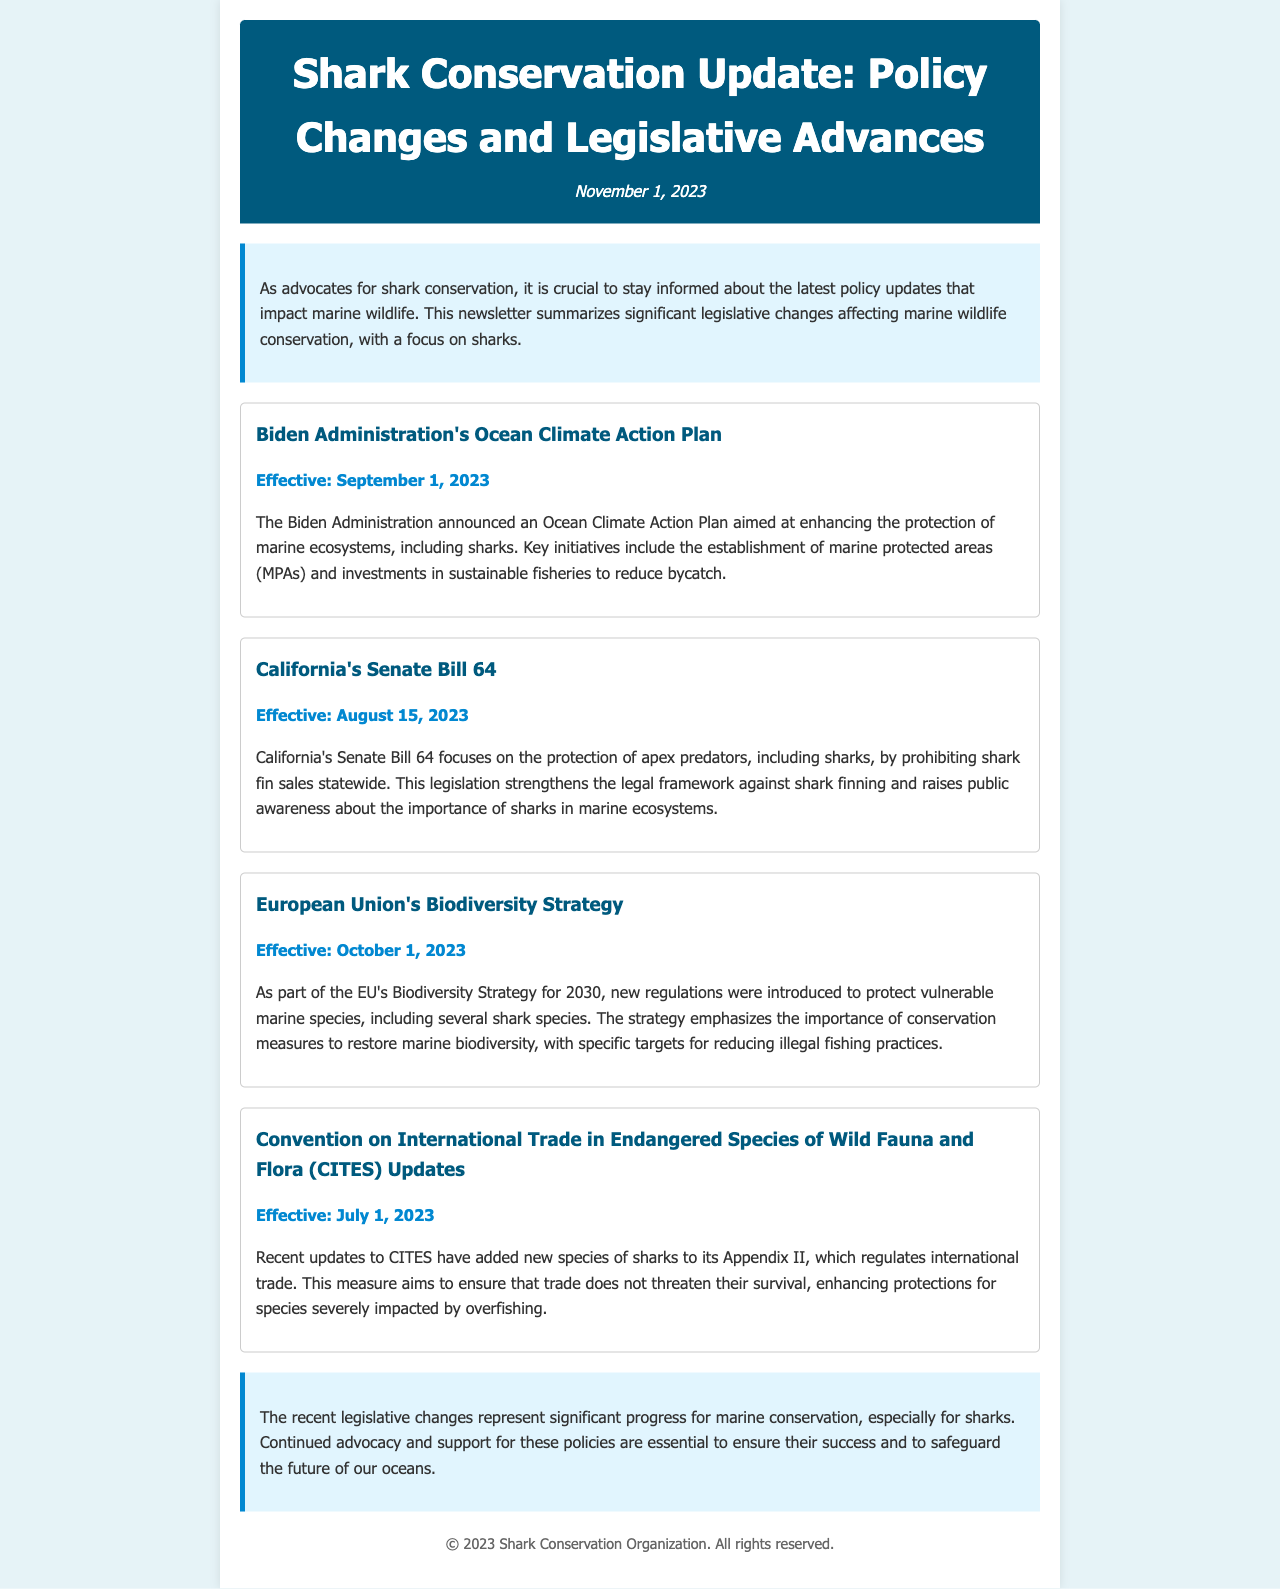What is the title of the newsletter? The title is stated in the header of the newsletter, which reflects its focus on policy changes related to marine wildlife conservation.
Answer: Shark Conservation Update: Policy Changes and Legislative Advances When was the Ocean Climate Action Plan effective? The effective date of the Ocean Climate Action Plan is mentioned in the policy update section, providing a specific timeline for its implementation.
Answer: September 1, 2023 What does California's Senate Bill 64 prohibit? This information is found in the description of California's Senate Bill 64, outlining its specific focus on shark conservation measures.
Answer: Shark fin sales Which organization announced updates to CITES? The updates to CITES are referenced within the legislative changes section of the document, pointing to the authority behind the regulation.
Answer: Convention on International Trade in Endangered Species of Wild Fauna and Flora (CITES) What is the main goal of the European Union's Biodiversity Strategy? This question requires understanding the overarching aim shared in the policy update, which encompasses a broader conservation agenda.
Answer: Restore marine biodiversity What species were added to CITES Appendix II? This refers to the specific actions taken in the updates to CITES, highlighting the legislative focus on certain species.
Answer: Species of sharks What are marine protected areas? This term is mentioned in the context of the Biden Administration's Ocean Climate Action Plan, indicating a key component of the initiative.
Answer: Areas established to protect marine ecosystems How many key initiatives are mentioned in the Ocean Climate Action Plan? The number of key initiatives can be inferred from the description provided, assessing the scope of the plan.
Answer: Two 